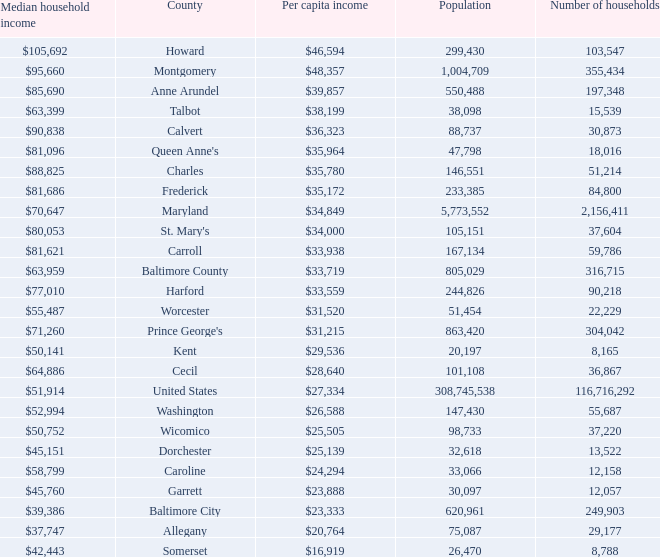What is the per capital income for Washington county? $26,588. 